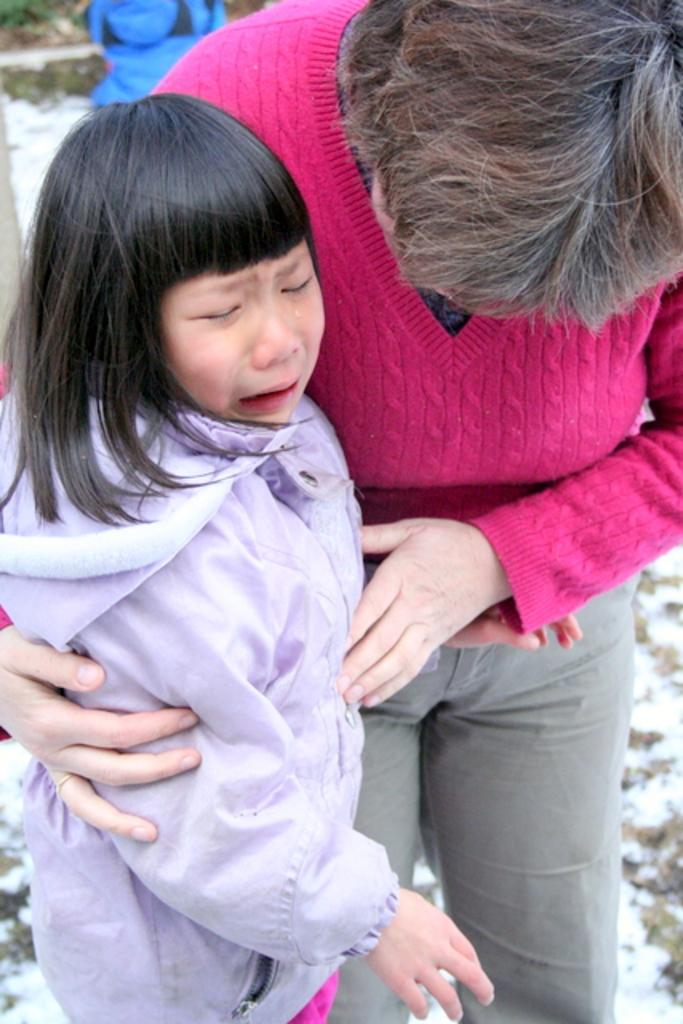Who is the main subject in the image? There is a girl in the image. What is the girl doing in the image? The girl is crying in the image. Can you describe the girl's hairstyle? The girl has bangs in the image. What is the girl wearing in the image? The girl is wearing a coat in the image. Who else is present in the image? There is another person in the image. What is the other person doing in the image? The other person is standing beside the girl in the image. Can you describe the other person's clothing? The other person is wearing a pink sweater in the image. What is the condition of the ground in the image? There is snow on the floor in the image. What type of watch is the girl wearing in the image? There is no watch visible in the image. What color is the skirt the girl is wearing in the image? The girl is not wearing a skirt in the image; she is wearing a coat. 